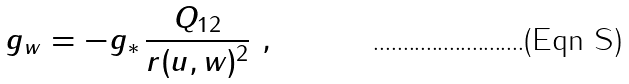<formula> <loc_0><loc_0><loc_500><loc_500>g _ { w } = - g _ { * } \, \frac { Q _ { 1 2 } } { r ( u , w ) ^ { 2 } } \ ,</formula> 